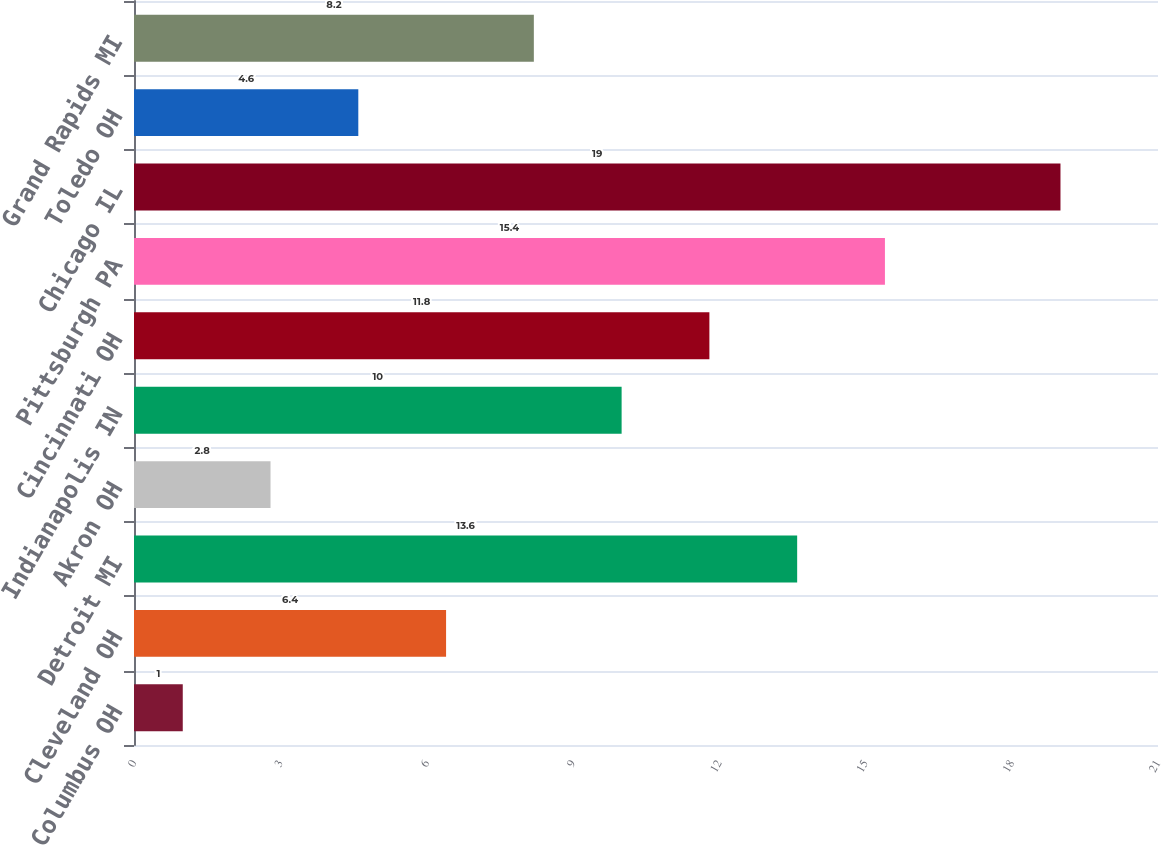<chart> <loc_0><loc_0><loc_500><loc_500><bar_chart><fcel>Columbus OH<fcel>Cleveland OH<fcel>Detroit MI<fcel>Akron OH<fcel>Indianapolis IN<fcel>Cincinnati OH<fcel>Pittsburgh PA<fcel>Chicago IL<fcel>Toledo OH<fcel>Grand Rapids MI<nl><fcel>1<fcel>6.4<fcel>13.6<fcel>2.8<fcel>10<fcel>11.8<fcel>15.4<fcel>19<fcel>4.6<fcel>8.2<nl></chart> 